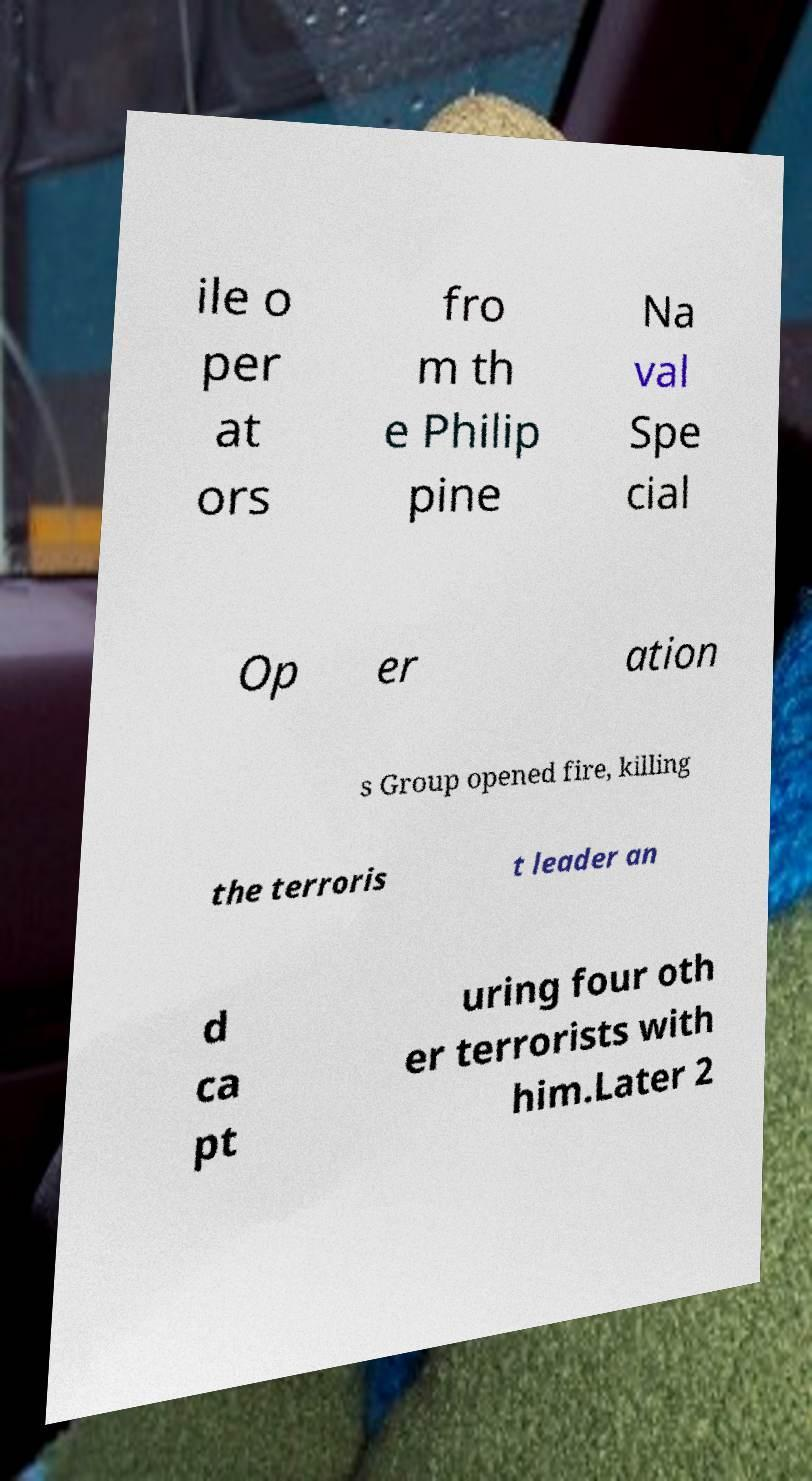What messages or text are displayed in this image? I need them in a readable, typed format. ile o per at ors fro m th e Philip pine Na val Spe cial Op er ation s Group opened fire, killing the terroris t leader an d ca pt uring four oth er terrorists with him.Later 2 